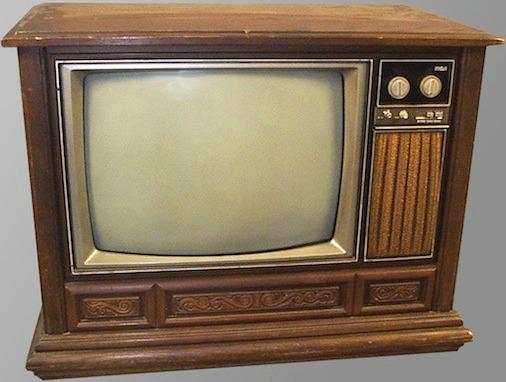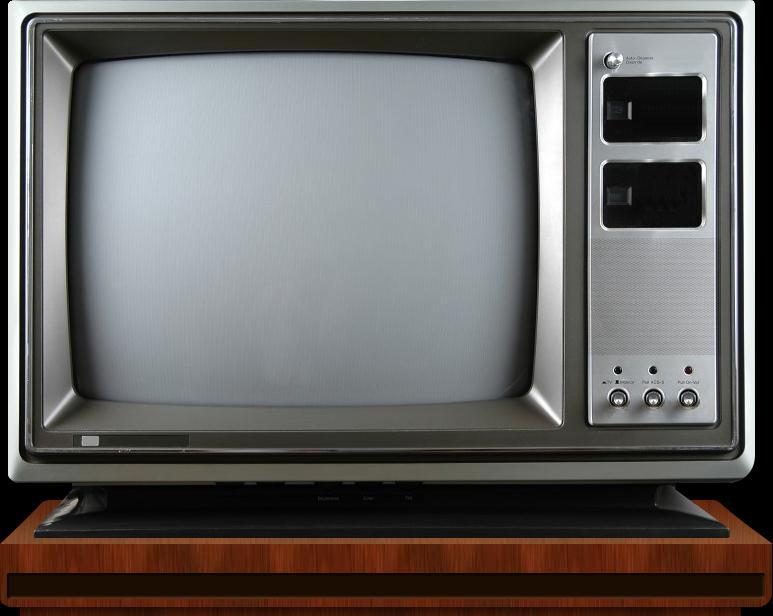The first image is the image on the left, the second image is the image on the right. Given the left and right images, does the statement "An image shows an old-fashioned wood-cased TV set elevated off the ground on some type of legs." hold true? Answer yes or no. No. 